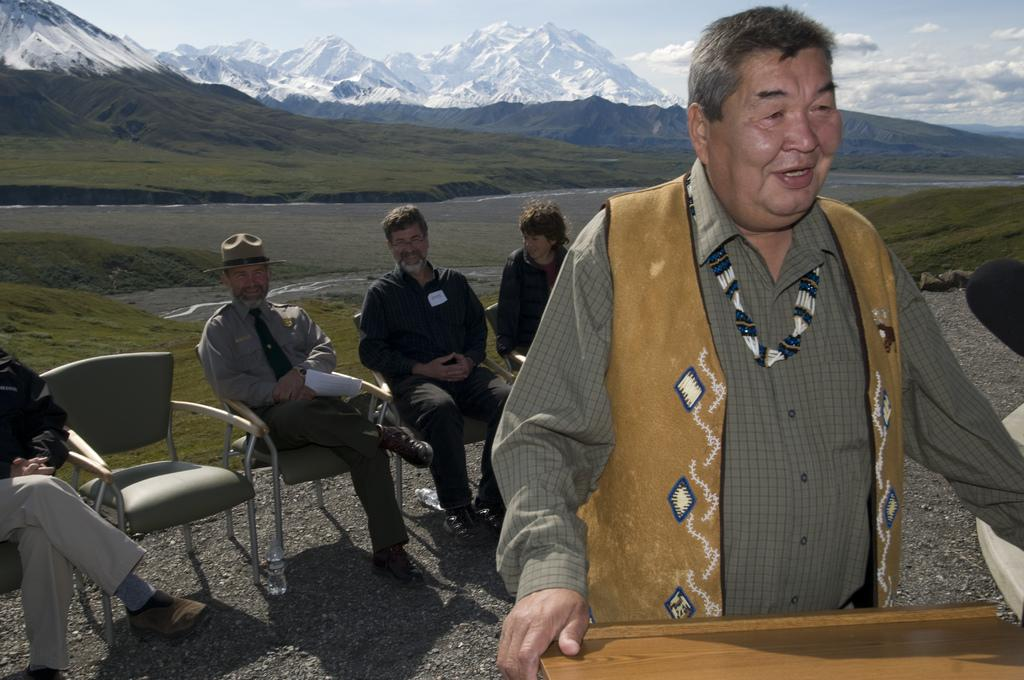What is the man in the image doing? The man is standing in the image and smiling. What are the people in the image doing? The people in the image are sitting on chairs. What can be seen in the background of the image? Mountains and the sky are visible in the background of the image. What is the condition of the sky in the image? The sky is visible in the background of the image, and clouds are present. How many bikes are being ridden by the donkey in the image? There are no bikes or donkeys present in the image. What is the purpose of the people sitting on chairs in the image? The image does not provide information about the purpose of the people sitting on chairs. 